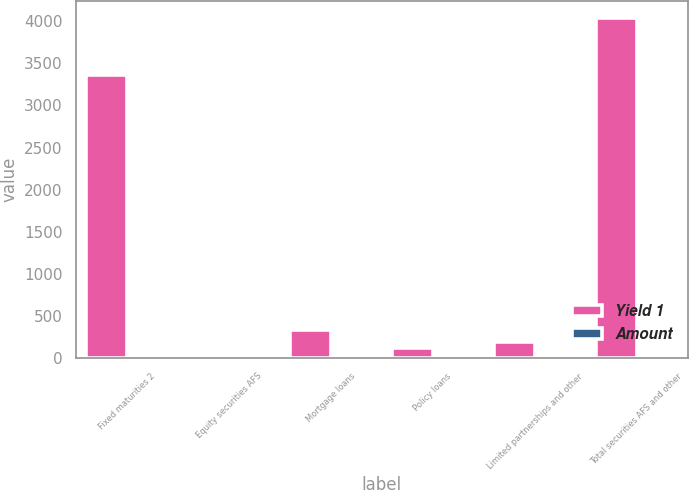<chart> <loc_0><loc_0><loc_500><loc_500><stacked_bar_chart><ecel><fcel>Fixed maturities 2<fcel>Equity securities AFS<fcel>Mortgage loans<fcel>Policy loans<fcel>Limited partnerships and other<fcel>Total securities AFS and other<nl><fcel>Yield 1<fcel>3363<fcel>37<fcel>337<fcel>119<fcel>196<fcel>4041<nl><fcel>Amount<fcel>4.2<fcel>4.3<fcel>5.2<fcel>6<fcel>7.1<fcel>4.3<nl></chart> 